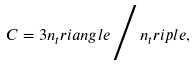<formula> <loc_0><loc_0><loc_500><loc_500>C = 3 n _ { t } r i a n g l e \, \Big / \, n _ { t } r i p l e ,</formula> 